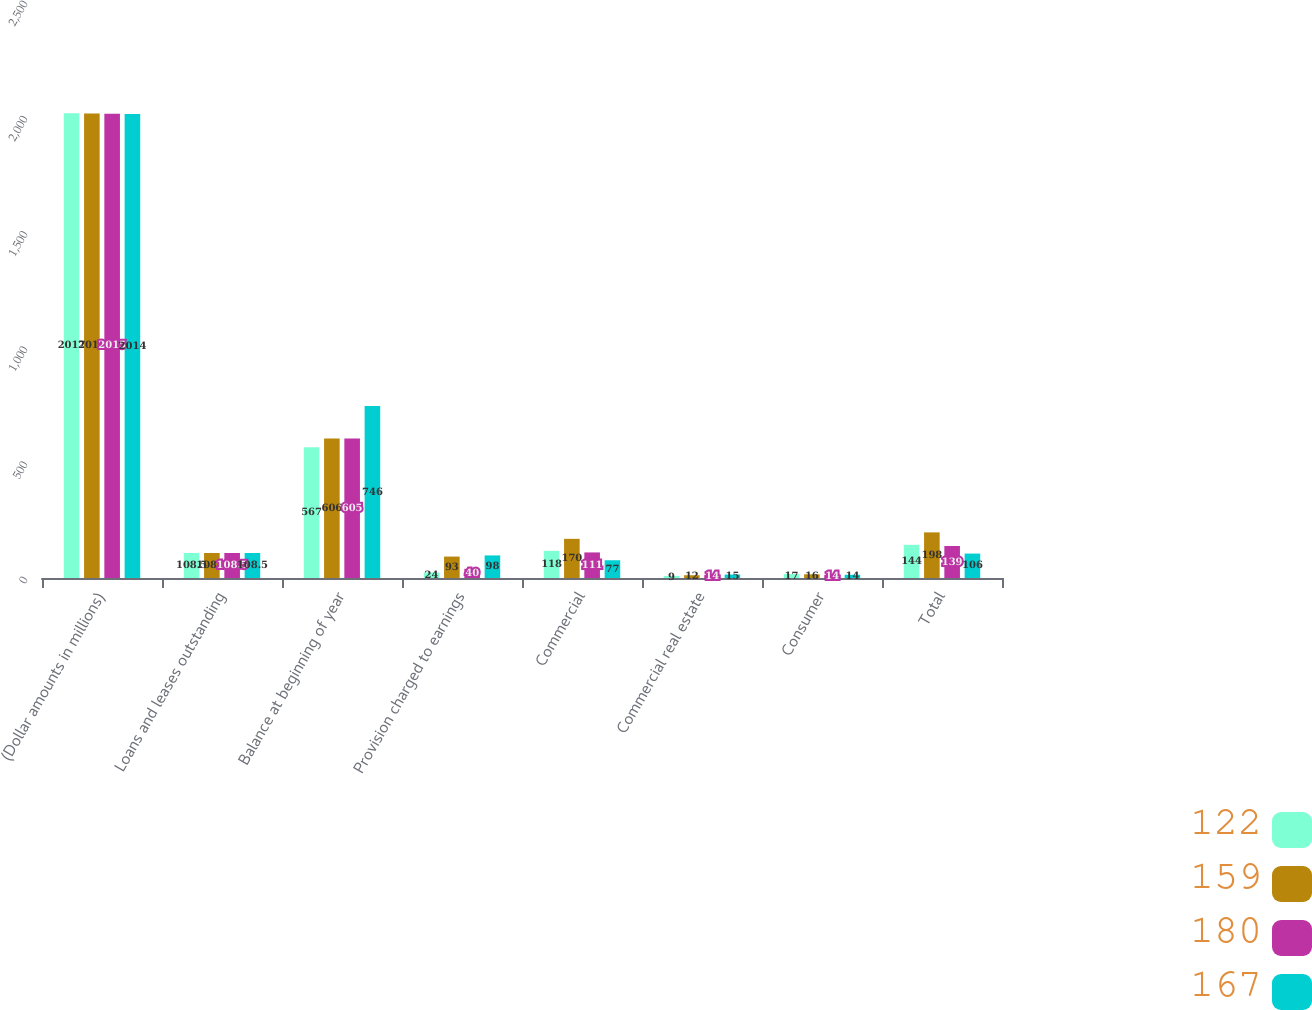Convert chart. <chart><loc_0><loc_0><loc_500><loc_500><stacked_bar_chart><ecel><fcel>(Dollar amounts in millions)<fcel>Loans and leases outstanding<fcel>Balance at beginning of year<fcel>Provision charged to earnings<fcel>Commercial<fcel>Commercial real estate<fcel>Consumer<fcel>Total<nl><fcel>122<fcel>2017<fcel>108.5<fcel>567<fcel>24<fcel>118<fcel>9<fcel>17<fcel>144<nl><fcel>159<fcel>2016<fcel>108.5<fcel>606<fcel>93<fcel>170<fcel>12<fcel>16<fcel>198<nl><fcel>180<fcel>2015<fcel>108.5<fcel>605<fcel>40<fcel>111<fcel>14<fcel>14<fcel>139<nl><fcel>167<fcel>2014<fcel>108.5<fcel>746<fcel>98<fcel>77<fcel>15<fcel>14<fcel>106<nl></chart> 